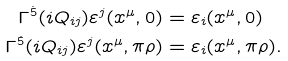<formula> <loc_0><loc_0><loc_500><loc_500>\Gamma ^ { \dot { 5 } } ( i Q _ { i j } ) \varepsilon ^ { j } ( x ^ { \mu } , 0 ) & = \varepsilon _ { i } ( x ^ { \mu } , 0 ) \\ \Gamma ^ { \dot { 5 } } ( i Q _ { i j } ) \varepsilon ^ { j } ( x ^ { \mu } , \pi \rho ) & = \varepsilon _ { i } ( x ^ { \mu } , \pi \rho ) .</formula> 